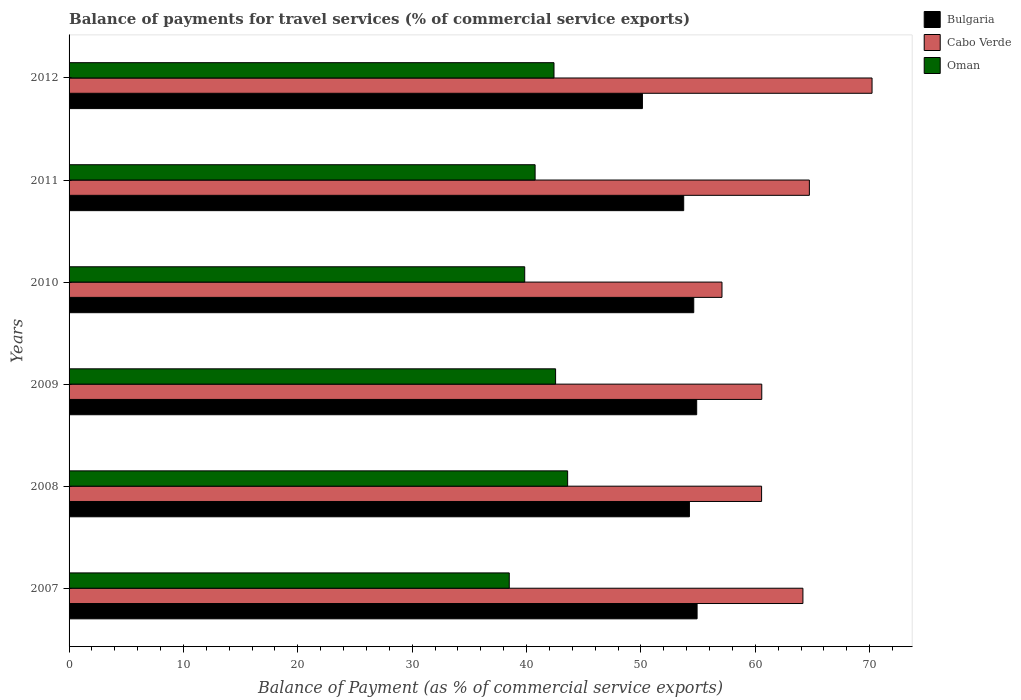How many different coloured bars are there?
Provide a short and direct response. 3. How many groups of bars are there?
Your response must be concise. 6. Are the number of bars per tick equal to the number of legend labels?
Offer a very short reply. Yes. How many bars are there on the 4th tick from the bottom?
Make the answer very short. 3. In how many cases, is the number of bars for a given year not equal to the number of legend labels?
Your answer should be compact. 0. What is the balance of payments for travel services in Cabo Verde in 2007?
Offer a terse response. 64.16. Across all years, what is the maximum balance of payments for travel services in Oman?
Ensure brevity in your answer.  43.59. Across all years, what is the minimum balance of payments for travel services in Bulgaria?
Your answer should be very brief. 50.13. In which year was the balance of payments for travel services in Cabo Verde maximum?
Keep it short and to the point. 2012. In which year was the balance of payments for travel services in Oman minimum?
Offer a very short reply. 2007. What is the total balance of payments for travel services in Bulgaria in the graph?
Ensure brevity in your answer.  322.49. What is the difference between the balance of payments for travel services in Bulgaria in 2011 and that in 2012?
Offer a very short reply. 3.61. What is the difference between the balance of payments for travel services in Cabo Verde in 2009 and the balance of payments for travel services in Bulgaria in 2011?
Provide a succinct answer. 6.82. What is the average balance of payments for travel services in Bulgaria per year?
Give a very brief answer. 53.75. In the year 2010, what is the difference between the balance of payments for travel services in Bulgaria and balance of payments for travel services in Oman?
Ensure brevity in your answer.  14.78. In how many years, is the balance of payments for travel services in Oman greater than 4 %?
Your response must be concise. 6. What is the ratio of the balance of payments for travel services in Cabo Verde in 2010 to that in 2012?
Give a very brief answer. 0.81. Is the difference between the balance of payments for travel services in Bulgaria in 2011 and 2012 greater than the difference between the balance of payments for travel services in Oman in 2011 and 2012?
Make the answer very short. Yes. What is the difference between the highest and the second highest balance of payments for travel services in Cabo Verde?
Provide a short and direct response. 5.48. What is the difference between the highest and the lowest balance of payments for travel services in Cabo Verde?
Keep it short and to the point. 13.12. Is the sum of the balance of payments for travel services in Oman in 2008 and 2010 greater than the maximum balance of payments for travel services in Cabo Verde across all years?
Offer a terse response. Yes. What does the 1st bar from the top in 2007 represents?
Ensure brevity in your answer.  Oman. What does the 2nd bar from the bottom in 2010 represents?
Your answer should be very brief. Cabo Verde. What is the difference between two consecutive major ticks on the X-axis?
Your answer should be compact. 10. Does the graph contain any zero values?
Give a very brief answer. No. Does the graph contain grids?
Provide a short and direct response. No. Where does the legend appear in the graph?
Your answer should be compact. Top right. What is the title of the graph?
Offer a terse response. Balance of payments for travel services (% of commercial service exports). Does "Turks and Caicos Islands" appear as one of the legend labels in the graph?
Keep it short and to the point. No. What is the label or title of the X-axis?
Keep it short and to the point. Balance of Payment (as % of commercial service exports). What is the Balance of Payment (as % of commercial service exports) in Bulgaria in 2007?
Your answer should be very brief. 54.91. What is the Balance of Payment (as % of commercial service exports) of Cabo Verde in 2007?
Provide a succinct answer. 64.16. What is the Balance of Payment (as % of commercial service exports) of Oman in 2007?
Provide a short and direct response. 38.49. What is the Balance of Payment (as % of commercial service exports) in Bulgaria in 2008?
Offer a very short reply. 54.24. What is the Balance of Payment (as % of commercial service exports) of Cabo Verde in 2008?
Provide a short and direct response. 60.55. What is the Balance of Payment (as % of commercial service exports) of Oman in 2008?
Your answer should be very brief. 43.59. What is the Balance of Payment (as % of commercial service exports) of Bulgaria in 2009?
Your answer should be very brief. 54.87. What is the Balance of Payment (as % of commercial service exports) of Cabo Verde in 2009?
Make the answer very short. 60.56. What is the Balance of Payment (as % of commercial service exports) of Oman in 2009?
Provide a short and direct response. 42.54. What is the Balance of Payment (as % of commercial service exports) in Bulgaria in 2010?
Make the answer very short. 54.61. What is the Balance of Payment (as % of commercial service exports) in Cabo Verde in 2010?
Give a very brief answer. 57.08. What is the Balance of Payment (as % of commercial service exports) in Oman in 2010?
Offer a terse response. 39.84. What is the Balance of Payment (as % of commercial service exports) of Bulgaria in 2011?
Your answer should be compact. 53.74. What is the Balance of Payment (as % of commercial service exports) of Cabo Verde in 2011?
Offer a terse response. 64.72. What is the Balance of Payment (as % of commercial service exports) of Oman in 2011?
Provide a succinct answer. 40.75. What is the Balance of Payment (as % of commercial service exports) in Bulgaria in 2012?
Make the answer very short. 50.13. What is the Balance of Payment (as % of commercial service exports) in Cabo Verde in 2012?
Offer a terse response. 70.2. What is the Balance of Payment (as % of commercial service exports) in Oman in 2012?
Offer a very short reply. 42.4. Across all years, what is the maximum Balance of Payment (as % of commercial service exports) in Bulgaria?
Provide a succinct answer. 54.91. Across all years, what is the maximum Balance of Payment (as % of commercial service exports) in Cabo Verde?
Offer a very short reply. 70.2. Across all years, what is the maximum Balance of Payment (as % of commercial service exports) in Oman?
Ensure brevity in your answer.  43.59. Across all years, what is the minimum Balance of Payment (as % of commercial service exports) in Bulgaria?
Keep it short and to the point. 50.13. Across all years, what is the minimum Balance of Payment (as % of commercial service exports) of Cabo Verde?
Provide a short and direct response. 57.08. Across all years, what is the minimum Balance of Payment (as % of commercial service exports) in Oman?
Your answer should be very brief. 38.49. What is the total Balance of Payment (as % of commercial service exports) of Bulgaria in the graph?
Provide a short and direct response. 322.49. What is the total Balance of Payment (as % of commercial service exports) in Cabo Verde in the graph?
Ensure brevity in your answer.  377.28. What is the total Balance of Payment (as % of commercial service exports) of Oman in the graph?
Offer a very short reply. 247.59. What is the difference between the Balance of Payment (as % of commercial service exports) of Bulgaria in 2007 and that in 2008?
Your answer should be compact. 0.67. What is the difference between the Balance of Payment (as % of commercial service exports) in Cabo Verde in 2007 and that in 2008?
Keep it short and to the point. 3.61. What is the difference between the Balance of Payment (as % of commercial service exports) in Oman in 2007 and that in 2008?
Your answer should be compact. -5.1. What is the difference between the Balance of Payment (as % of commercial service exports) in Bulgaria in 2007 and that in 2009?
Your response must be concise. 0.04. What is the difference between the Balance of Payment (as % of commercial service exports) of Cabo Verde in 2007 and that in 2009?
Provide a succinct answer. 3.6. What is the difference between the Balance of Payment (as % of commercial service exports) in Oman in 2007 and that in 2009?
Your answer should be compact. -4.05. What is the difference between the Balance of Payment (as % of commercial service exports) of Bulgaria in 2007 and that in 2010?
Give a very brief answer. 0.29. What is the difference between the Balance of Payment (as % of commercial service exports) of Cabo Verde in 2007 and that in 2010?
Your answer should be very brief. 7.08. What is the difference between the Balance of Payment (as % of commercial service exports) in Oman in 2007 and that in 2010?
Make the answer very short. -1.35. What is the difference between the Balance of Payment (as % of commercial service exports) in Bulgaria in 2007 and that in 2011?
Make the answer very short. 1.17. What is the difference between the Balance of Payment (as % of commercial service exports) of Cabo Verde in 2007 and that in 2011?
Ensure brevity in your answer.  -0.56. What is the difference between the Balance of Payment (as % of commercial service exports) in Oman in 2007 and that in 2011?
Ensure brevity in your answer.  -2.26. What is the difference between the Balance of Payment (as % of commercial service exports) in Bulgaria in 2007 and that in 2012?
Ensure brevity in your answer.  4.78. What is the difference between the Balance of Payment (as % of commercial service exports) of Cabo Verde in 2007 and that in 2012?
Make the answer very short. -6.04. What is the difference between the Balance of Payment (as % of commercial service exports) in Oman in 2007 and that in 2012?
Ensure brevity in your answer.  -3.91. What is the difference between the Balance of Payment (as % of commercial service exports) of Bulgaria in 2008 and that in 2009?
Offer a very short reply. -0.64. What is the difference between the Balance of Payment (as % of commercial service exports) of Cabo Verde in 2008 and that in 2009?
Give a very brief answer. -0.02. What is the difference between the Balance of Payment (as % of commercial service exports) in Oman in 2008 and that in 2009?
Ensure brevity in your answer.  1.05. What is the difference between the Balance of Payment (as % of commercial service exports) in Bulgaria in 2008 and that in 2010?
Ensure brevity in your answer.  -0.38. What is the difference between the Balance of Payment (as % of commercial service exports) of Cabo Verde in 2008 and that in 2010?
Provide a succinct answer. 3.46. What is the difference between the Balance of Payment (as % of commercial service exports) of Oman in 2008 and that in 2010?
Make the answer very short. 3.75. What is the difference between the Balance of Payment (as % of commercial service exports) in Bulgaria in 2008 and that in 2011?
Your answer should be compact. 0.5. What is the difference between the Balance of Payment (as % of commercial service exports) in Cabo Verde in 2008 and that in 2011?
Provide a succinct answer. -4.18. What is the difference between the Balance of Payment (as % of commercial service exports) of Oman in 2008 and that in 2011?
Offer a very short reply. 2.84. What is the difference between the Balance of Payment (as % of commercial service exports) of Bulgaria in 2008 and that in 2012?
Provide a short and direct response. 4.11. What is the difference between the Balance of Payment (as % of commercial service exports) in Cabo Verde in 2008 and that in 2012?
Ensure brevity in your answer.  -9.66. What is the difference between the Balance of Payment (as % of commercial service exports) in Oman in 2008 and that in 2012?
Your answer should be compact. 1.19. What is the difference between the Balance of Payment (as % of commercial service exports) of Bulgaria in 2009 and that in 2010?
Your answer should be very brief. 0.26. What is the difference between the Balance of Payment (as % of commercial service exports) in Cabo Verde in 2009 and that in 2010?
Your answer should be compact. 3.48. What is the difference between the Balance of Payment (as % of commercial service exports) in Oman in 2009 and that in 2010?
Ensure brevity in your answer.  2.7. What is the difference between the Balance of Payment (as % of commercial service exports) in Bulgaria in 2009 and that in 2011?
Keep it short and to the point. 1.13. What is the difference between the Balance of Payment (as % of commercial service exports) of Cabo Verde in 2009 and that in 2011?
Make the answer very short. -4.16. What is the difference between the Balance of Payment (as % of commercial service exports) of Oman in 2009 and that in 2011?
Ensure brevity in your answer.  1.79. What is the difference between the Balance of Payment (as % of commercial service exports) of Bulgaria in 2009 and that in 2012?
Offer a very short reply. 4.74. What is the difference between the Balance of Payment (as % of commercial service exports) in Cabo Verde in 2009 and that in 2012?
Ensure brevity in your answer.  -9.64. What is the difference between the Balance of Payment (as % of commercial service exports) of Oman in 2009 and that in 2012?
Provide a succinct answer. 0.14. What is the difference between the Balance of Payment (as % of commercial service exports) in Bulgaria in 2010 and that in 2011?
Offer a very short reply. 0.88. What is the difference between the Balance of Payment (as % of commercial service exports) of Cabo Verde in 2010 and that in 2011?
Your answer should be compact. -7.64. What is the difference between the Balance of Payment (as % of commercial service exports) of Oman in 2010 and that in 2011?
Provide a short and direct response. -0.91. What is the difference between the Balance of Payment (as % of commercial service exports) in Bulgaria in 2010 and that in 2012?
Offer a terse response. 4.49. What is the difference between the Balance of Payment (as % of commercial service exports) in Cabo Verde in 2010 and that in 2012?
Provide a succinct answer. -13.12. What is the difference between the Balance of Payment (as % of commercial service exports) of Oman in 2010 and that in 2012?
Keep it short and to the point. -2.56. What is the difference between the Balance of Payment (as % of commercial service exports) of Bulgaria in 2011 and that in 2012?
Your response must be concise. 3.61. What is the difference between the Balance of Payment (as % of commercial service exports) in Cabo Verde in 2011 and that in 2012?
Provide a succinct answer. -5.48. What is the difference between the Balance of Payment (as % of commercial service exports) in Oman in 2011 and that in 2012?
Provide a short and direct response. -1.65. What is the difference between the Balance of Payment (as % of commercial service exports) of Bulgaria in 2007 and the Balance of Payment (as % of commercial service exports) of Cabo Verde in 2008?
Give a very brief answer. -5.64. What is the difference between the Balance of Payment (as % of commercial service exports) in Bulgaria in 2007 and the Balance of Payment (as % of commercial service exports) in Oman in 2008?
Your response must be concise. 11.32. What is the difference between the Balance of Payment (as % of commercial service exports) of Cabo Verde in 2007 and the Balance of Payment (as % of commercial service exports) of Oman in 2008?
Provide a short and direct response. 20.57. What is the difference between the Balance of Payment (as % of commercial service exports) in Bulgaria in 2007 and the Balance of Payment (as % of commercial service exports) in Cabo Verde in 2009?
Your answer should be very brief. -5.65. What is the difference between the Balance of Payment (as % of commercial service exports) of Bulgaria in 2007 and the Balance of Payment (as % of commercial service exports) of Oman in 2009?
Your answer should be compact. 12.37. What is the difference between the Balance of Payment (as % of commercial service exports) in Cabo Verde in 2007 and the Balance of Payment (as % of commercial service exports) in Oman in 2009?
Make the answer very short. 21.62. What is the difference between the Balance of Payment (as % of commercial service exports) in Bulgaria in 2007 and the Balance of Payment (as % of commercial service exports) in Cabo Verde in 2010?
Ensure brevity in your answer.  -2.18. What is the difference between the Balance of Payment (as % of commercial service exports) in Bulgaria in 2007 and the Balance of Payment (as % of commercial service exports) in Oman in 2010?
Provide a short and direct response. 15.07. What is the difference between the Balance of Payment (as % of commercial service exports) in Cabo Verde in 2007 and the Balance of Payment (as % of commercial service exports) in Oman in 2010?
Your response must be concise. 24.32. What is the difference between the Balance of Payment (as % of commercial service exports) in Bulgaria in 2007 and the Balance of Payment (as % of commercial service exports) in Cabo Verde in 2011?
Provide a succinct answer. -9.82. What is the difference between the Balance of Payment (as % of commercial service exports) of Bulgaria in 2007 and the Balance of Payment (as % of commercial service exports) of Oman in 2011?
Provide a short and direct response. 14.16. What is the difference between the Balance of Payment (as % of commercial service exports) of Cabo Verde in 2007 and the Balance of Payment (as % of commercial service exports) of Oman in 2011?
Make the answer very short. 23.41. What is the difference between the Balance of Payment (as % of commercial service exports) in Bulgaria in 2007 and the Balance of Payment (as % of commercial service exports) in Cabo Verde in 2012?
Your response must be concise. -15.3. What is the difference between the Balance of Payment (as % of commercial service exports) in Bulgaria in 2007 and the Balance of Payment (as % of commercial service exports) in Oman in 2012?
Your answer should be compact. 12.51. What is the difference between the Balance of Payment (as % of commercial service exports) of Cabo Verde in 2007 and the Balance of Payment (as % of commercial service exports) of Oman in 2012?
Ensure brevity in your answer.  21.76. What is the difference between the Balance of Payment (as % of commercial service exports) in Bulgaria in 2008 and the Balance of Payment (as % of commercial service exports) in Cabo Verde in 2009?
Offer a terse response. -6.33. What is the difference between the Balance of Payment (as % of commercial service exports) in Bulgaria in 2008 and the Balance of Payment (as % of commercial service exports) in Oman in 2009?
Ensure brevity in your answer.  11.7. What is the difference between the Balance of Payment (as % of commercial service exports) of Cabo Verde in 2008 and the Balance of Payment (as % of commercial service exports) of Oman in 2009?
Give a very brief answer. 18.01. What is the difference between the Balance of Payment (as % of commercial service exports) of Bulgaria in 2008 and the Balance of Payment (as % of commercial service exports) of Cabo Verde in 2010?
Offer a terse response. -2.85. What is the difference between the Balance of Payment (as % of commercial service exports) of Bulgaria in 2008 and the Balance of Payment (as % of commercial service exports) of Oman in 2010?
Your answer should be compact. 14.4. What is the difference between the Balance of Payment (as % of commercial service exports) of Cabo Verde in 2008 and the Balance of Payment (as % of commercial service exports) of Oman in 2010?
Offer a terse response. 20.71. What is the difference between the Balance of Payment (as % of commercial service exports) of Bulgaria in 2008 and the Balance of Payment (as % of commercial service exports) of Cabo Verde in 2011?
Provide a short and direct response. -10.49. What is the difference between the Balance of Payment (as % of commercial service exports) in Bulgaria in 2008 and the Balance of Payment (as % of commercial service exports) in Oman in 2011?
Offer a terse response. 13.49. What is the difference between the Balance of Payment (as % of commercial service exports) in Cabo Verde in 2008 and the Balance of Payment (as % of commercial service exports) in Oman in 2011?
Keep it short and to the point. 19.8. What is the difference between the Balance of Payment (as % of commercial service exports) in Bulgaria in 2008 and the Balance of Payment (as % of commercial service exports) in Cabo Verde in 2012?
Make the answer very short. -15.97. What is the difference between the Balance of Payment (as % of commercial service exports) of Bulgaria in 2008 and the Balance of Payment (as % of commercial service exports) of Oman in 2012?
Your answer should be very brief. 11.84. What is the difference between the Balance of Payment (as % of commercial service exports) of Cabo Verde in 2008 and the Balance of Payment (as % of commercial service exports) of Oman in 2012?
Give a very brief answer. 18.15. What is the difference between the Balance of Payment (as % of commercial service exports) of Bulgaria in 2009 and the Balance of Payment (as % of commercial service exports) of Cabo Verde in 2010?
Offer a very short reply. -2.21. What is the difference between the Balance of Payment (as % of commercial service exports) in Bulgaria in 2009 and the Balance of Payment (as % of commercial service exports) in Oman in 2010?
Your answer should be very brief. 15.03. What is the difference between the Balance of Payment (as % of commercial service exports) in Cabo Verde in 2009 and the Balance of Payment (as % of commercial service exports) in Oman in 2010?
Your response must be concise. 20.73. What is the difference between the Balance of Payment (as % of commercial service exports) in Bulgaria in 2009 and the Balance of Payment (as % of commercial service exports) in Cabo Verde in 2011?
Ensure brevity in your answer.  -9.85. What is the difference between the Balance of Payment (as % of commercial service exports) of Bulgaria in 2009 and the Balance of Payment (as % of commercial service exports) of Oman in 2011?
Offer a terse response. 14.13. What is the difference between the Balance of Payment (as % of commercial service exports) in Cabo Verde in 2009 and the Balance of Payment (as % of commercial service exports) in Oman in 2011?
Offer a terse response. 19.82. What is the difference between the Balance of Payment (as % of commercial service exports) in Bulgaria in 2009 and the Balance of Payment (as % of commercial service exports) in Cabo Verde in 2012?
Keep it short and to the point. -15.33. What is the difference between the Balance of Payment (as % of commercial service exports) in Bulgaria in 2009 and the Balance of Payment (as % of commercial service exports) in Oman in 2012?
Offer a very short reply. 12.47. What is the difference between the Balance of Payment (as % of commercial service exports) of Cabo Verde in 2009 and the Balance of Payment (as % of commercial service exports) of Oman in 2012?
Your answer should be compact. 18.16. What is the difference between the Balance of Payment (as % of commercial service exports) in Bulgaria in 2010 and the Balance of Payment (as % of commercial service exports) in Cabo Verde in 2011?
Give a very brief answer. -10.11. What is the difference between the Balance of Payment (as % of commercial service exports) in Bulgaria in 2010 and the Balance of Payment (as % of commercial service exports) in Oman in 2011?
Provide a short and direct response. 13.87. What is the difference between the Balance of Payment (as % of commercial service exports) of Cabo Verde in 2010 and the Balance of Payment (as % of commercial service exports) of Oman in 2011?
Ensure brevity in your answer.  16.34. What is the difference between the Balance of Payment (as % of commercial service exports) of Bulgaria in 2010 and the Balance of Payment (as % of commercial service exports) of Cabo Verde in 2012?
Keep it short and to the point. -15.59. What is the difference between the Balance of Payment (as % of commercial service exports) of Bulgaria in 2010 and the Balance of Payment (as % of commercial service exports) of Oman in 2012?
Ensure brevity in your answer.  12.22. What is the difference between the Balance of Payment (as % of commercial service exports) in Cabo Verde in 2010 and the Balance of Payment (as % of commercial service exports) in Oman in 2012?
Provide a short and direct response. 14.69. What is the difference between the Balance of Payment (as % of commercial service exports) of Bulgaria in 2011 and the Balance of Payment (as % of commercial service exports) of Cabo Verde in 2012?
Give a very brief answer. -16.47. What is the difference between the Balance of Payment (as % of commercial service exports) in Bulgaria in 2011 and the Balance of Payment (as % of commercial service exports) in Oman in 2012?
Provide a succinct answer. 11.34. What is the difference between the Balance of Payment (as % of commercial service exports) in Cabo Verde in 2011 and the Balance of Payment (as % of commercial service exports) in Oman in 2012?
Provide a succinct answer. 22.33. What is the average Balance of Payment (as % of commercial service exports) in Bulgaria per year?
Provide a short and direct response. 53.75. What is the average Balance of Payment (as % of commercial service exports) of Cabo Verde per year?
Provide a short and direct response. 62.88. What is the average Balance of Payment (as % of commercial service exports) of Oman per year?
Give a very brief answer. 41.27. In the year 2007, what is the difference between the Balance of Payment (as % of commercial service exports) of Bulgaria and Balance of Payment (as % of commercial service exports) of Cabo Verde?
Provide a short and direct response. -9.25. In the year 2007, what is the difference between the Balance of Payment (as % of commercial service exports) of Bulgaria and Balance of Payment (as % of commercial service exports) of Oman?
Your answer should be compact. 16.42. In the year 2007, what is the difference between the Balance of Payment (as % of commercial service exports) of Cabo Verde and Balance of Payment (as % of commercial service exports) of Oman?
Make the answer very short. 25.67. In the year 2008, what is the difference between the Balance of Payment (as % of commercial service exports) in Bulgaria and Balance of Payment (as % of commercial service exports) in Cabo Verde?
Make the answer very short. -6.31. In the year 2008, what is the difference between the Balance of Payment (as % of commercial service exports) of Bulgaria and Balance of Payment (as % of commercial service exports) of Oman?
Your answer should be very brief. 10.65. In the year 2008, what is the difference between the Balance of Payment (as % of commercial service exports) of Cabo Verde and Balance of Payment (as % of commercial service exports) of Oman?
Your response must be concise. 16.96. In the year 2009, what is the difference between the Balance of Payment (as % of commercial service exports) in Bulgaria and Balance of Payment (as % of commercial service exports) in Cabo Verde?
Your answer should be very brief. -5.69. In the year 2009, what is the difference between the Balance of Payment (as % of commercial service exports) of Bulgaria and Balance of Payment (as % of commercial service exports) of Oman?
Ensure brevity in your answer.  12.34. In the year 2009, what is the difference between the Balance of Payment (as % of commercial service exports) of Cabo Verde and Balance of Payment (as % of commercial service exports) of Oman?
Keep it short and to the point. 18.03. In the year 2010, what is the difference between the Balance of Payment (as % of commercial service exports) in Bulgaria and Balance of Payment (as % of commercial service exports) in Cabo Verde?
Ensure brevity in your answer.  -2.47. In the year 2010, what is the difference between the Balance of Payment (as % of commercial service exports) in Bulgaria and Balance of Payment (as % of commercial service exports) in Oman?
Provide a succinct answer. 14.78. In the year 2010, what is the difference between the Balance of Payment (as % of commercial service exports) in Cabo Verde and Balance of Payment (as % of commercial service exports) in Oman?
Provide a succinct answer. 17.25. In the year 2011, what is the difference between the Balance of Payment (as % of commercial service exports) of Bulgaria and Balance of Payment (as % of commercial service exports) of Cabo Verde?
Your answer should be compact. -10.99. In the year 2011, what is the difference between the Balance of Payment (as % of commercial service exports) in Bulgaria and Balance of Payment (as % of commercial service exports) in Oman?
Provide a short and direct response. 12.99. In the year 2011, what is the difference between the Balance of Payment (as % of commercial service exports) in Cabo Verde and Balance of Payment (as % of commercial service exports) in Oman?
Make the answer very short. 23.98. In the year 2012, what is the difference between the Balance of Payment (as % of commercial service exports) of Bulgaria and Balance of Payment (as % of commercial service exports) of Cabo Verde?
Your answer should be compact. -20.08. In the year 2012, what is the difference between the Balance of Payment (as % of commercial service exports) of Bulgaria and Balance of Payment (as % of commercial service exports) of Oman?
Ensure brevity in your answer.  7.73. In the year 2012, what is the difference between the Balance of Payment (as % of commercial service exports) of Cabo Verde and Balance of Payment (as % of commercial service exports) of Oman?
Your answer should be very brief. 27.81. What is the ratio of the Balance of Payment (as % of commercial service exports) of Bulgaria in 2007 to that in 2008?
Your answer should be compact. 1.01. What is the ratio of the Balance of Payment (as % of commercial service exports) of Cabo Verde in 2007 to that in 2008?
Your answer should be very brief. 1.06. What is the ratio of the Balance of Payment (as % of commercial service exports) in Oman in 2007 to that in 2008?
Your answer should be very brief. 0.88. What is the ratio of the Balance of Payment (as % of commercial service exports) in Cabo Verde in 2007 to that in 2009?
Provide a succinct answer. 1.06. What is the ratio of the Balance of Payment (as % of commercial service exports) of Oman in 2007 to that in 2009?
Offer a very short reply. 0.9. What is the ratio of the Balance of Payment (as % of commercial service exports) in Bulgaria in 2007 to that in 2010?
Offer a very short reply. 1.01. What is the ratio of the Balance of Payment (as % of commercial service exports) in Cabo Verde in 2007 to that in 2010?
Offer a terse response. 1.12. What is the ratio of the Balance of Payment (as % of commercial service exports) of Oman in 2007 to that in 2010?
Give a very brief answer. 0.97. What is the ratio of the Balance of Payment (as % of commercial service exports) in Bulgaria in 2007 to that in 2011?
Your answer should be compact. 1.02. What is the ratio of the Balance of Payment (as % of commercial service exports) in Cabo Verde in 2007 to that in 2011?
Make the answer very short. 0.99. What is the ratio of the Balance of Payment (as % of commercial service exports) in Oman in 2007 to that in 2011?
Your answer should be very brief. 0.94. What is the ratio of the Balance of Payment (as % of commercial service exports) in Bulgaria in 2007 to that in 2012?
Provide a succinct answer. 1.1. What is the ratio of the Balance of Payment (as % of commercial service exports) in Cabo Verde in 2007 to that in 2012?
Your response must be concise. 0.91. What is the ratio of the Balance of Payment (as % of commercial service exports) of Oman in 2007 to that in 2012?
Give a very brief answer. 0.91. What is the ratio of the Balance of Payment (as % of commercial service exports) of Bulgaria in 2008 to that in 2009?
Offer a terse response. 0.99. What is the ratio of the Balance of Payment (as % of commercial service exports) in Cabo Verde in 2008 to that in 2009?
Offer a terse response. 1. What is the ratio of the Balance of Payment (as % of commercial service exports) of Oman in 2008 to that in 2009?
Keep it short and to the point. 1.02. What is the ratio of the Balance of Payment (as % of commercial service exports) in Cabo Verde in 2008 to that in 2010?
Offer a terse response. 1.06. What is the ratio of the Balance of Payment (as % of commercial service exports) in Oman in 2008 to that in 2010?
Offer a very short reply. 1.09. What is the ratio of the Balance of Payment (as % of commercial service exports) of Bulgaria in 2008 to that in 2011?
Ensure brevity in your answer.  1.01. What is the ratio of the Balance of Payment (as % of commercial service exports) of Cabo Verde in 2008 to that in 2011?
Keep it short and to the point. 0.94. What is the ratio of the Balance of Payment (as % of commercial service exports) of Oman in 2008 to that in 2011?
Offer a very short reply. 1.07. What is the ratio of the Balance of Payment (as % of commercial service exports) in Bulgaria in 2008 to that in 2012?
Your answer should be very brief. 1.08. What is the ratio of the Balance of Payment (as % of commercial service exports) in Cabo Verde in 2008 to that in 2012?
Give a very brief answer. 0.86. What is the ratio of the Balance of Payment (as % of commercial service exports) of Oman in 2008 to that in 2012?
Offer a terse response. 1.03. What is the ratio of the Balance of Payment (as % of commercial service exports) in Cabo Verde in 2009 to that in 2010?
Offer a very short reply. 1.06. What is the ratio of the Balance of Payment (as % of commercial service exports) in Oman in 2009 to that in 2010?
Provide a short and direct response. 1.07. What is the ratio of the Balance of Payment (as % of commercial service exports) in Bulgaria in 2009 to that in 2011?
Make the answer very short. 1.02. What is the ratio of the Balance of Payment (as % of commercial service exports) of Cabo Verde in 2009 to that in 2011?
Provide a short and direct response. 0.94. What is the ratio of the Balance of Payment (as % of commercial service exports) in Oman in 2009 to that in 2011?
Give a very brief answer. 1.04. What is the ratio of the Balance of Payment (as % of commercial service exports) in Bulgaria in 2009 to that in 2012?
Keep it short and to the point. 1.09. What is the ratio of the Balance of Payment (as % of commercial service exports) of Cabo Verde in 2009 to that in 2012?
Provide a succinct answer. 0.86. What is the ratio of the Balance of Payment (as % of commercial service exports) in Oman in 2009 to that in 2012?
Your answer should be very brief. 1. What is the ratio of the Balance of Payment (as % of commercial service exports) of Bulgaria in 2010 to that in 2011?
Offer a very short reply. 1.02. What is the ratio of the Balance of Payment (as % of commercial service exports) in Cabo Verde in 2010 to that in 2011?
Give a very brief answer. 0.88. What is the ratio of the Balance of Payment (as % of commercial service exports) in Oman in 2010 to that in 2011?
Keep it short and to the point. 0.98. What is the ratio of the Balance of Payment (as % of commercial service exports) in Bulgaria in 2010 to that in 2012?
Ensure brevity in your answer.  1.09. What is the ratio of the Balance of Payment (as % of commercial service exports) in Cabo Verde in 2010 to that in 2012?
Provide a short and direct response. 0.81. What is the ratio of the Balance of Payment (as % of commercial service exports) in Oman in 2010 to that in 2012?
Ensure brevity in your answer.  0.94. What is the ratio of the Balance of Payment (as % of commercial service exports) of Bulgaria in 2011 to that in 2012?
Your answer should be compact. 1.07. What is the ratio of the Balance of Payment (as % of commercial service exports) of Cabo Verde in 2011 to that in 2012?
Offer a terse response. 0.92. What is the ratio of the Balance of Payment (as % of commercial service exports) in Oman in 2011 to that in 2012?
Offer a very short reply. 0.96. What is the difference between the highest and the second highest Balance of Payment (as % of commercial service exports) in Bulgaria?
Keep it short and to the point. 0.04. What is the difference between the highest and the second highest Balance of Payment (as % of commercial service exports) of Cabo Verde?
Ensure brevity in your answer.  5.48. What is the difference between the highest and the second highest Balance of Payment (as % of commercial service exports) in Oman?
Offer a very short reply. 1.05. What is the difference between the highest and the lowest Balance of Payment (as % of commercial service exports) in Bulgaria?
Offer a very short reply. 4.78. What is the difference between the highest and the lowest Balance of Payment (as % of commercial service exports) in Cabo Verde?
Provide a succinct answer. 13.12. What is the difference between the highest and the lowest Balance of Payment (as % of commercial service exports) in Oman?
Offer a very short reply. 5.1. 